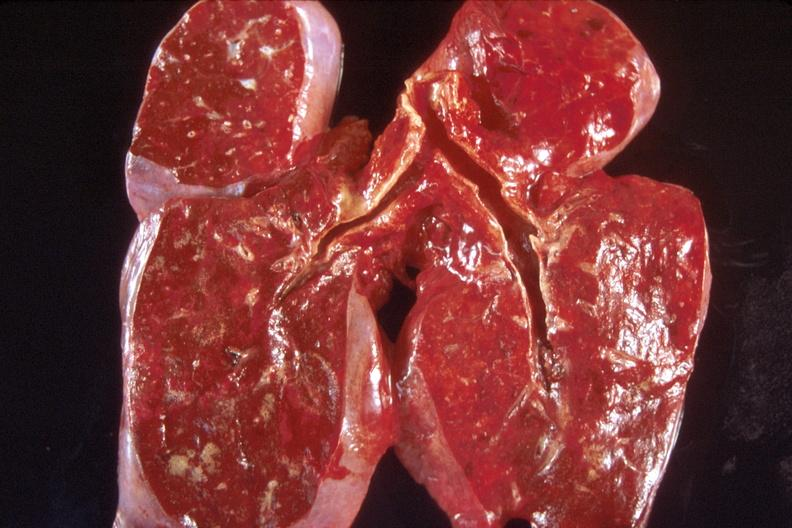s respiratory present?
Answer the question using a single word or phrase. Yes 